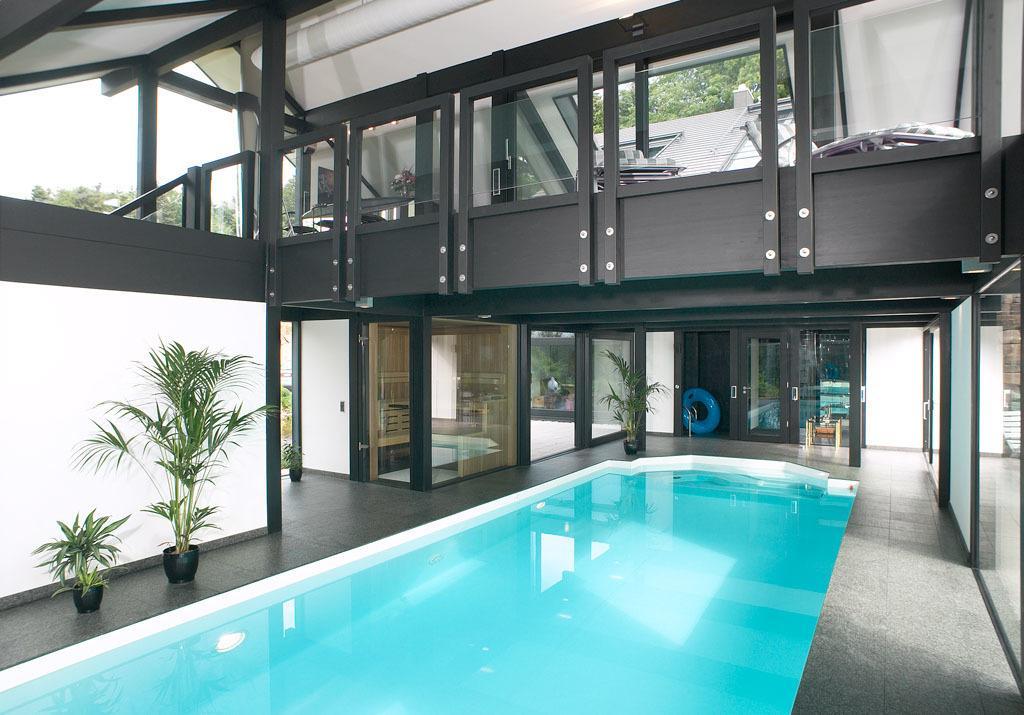Describe this image in one or two sentences. In this image we can see the inside view of the house, there are house plants, there is a tube, windows, trees, also we can see the reflection of trees on the mirror, also we can see the sky, and swimming pool. 